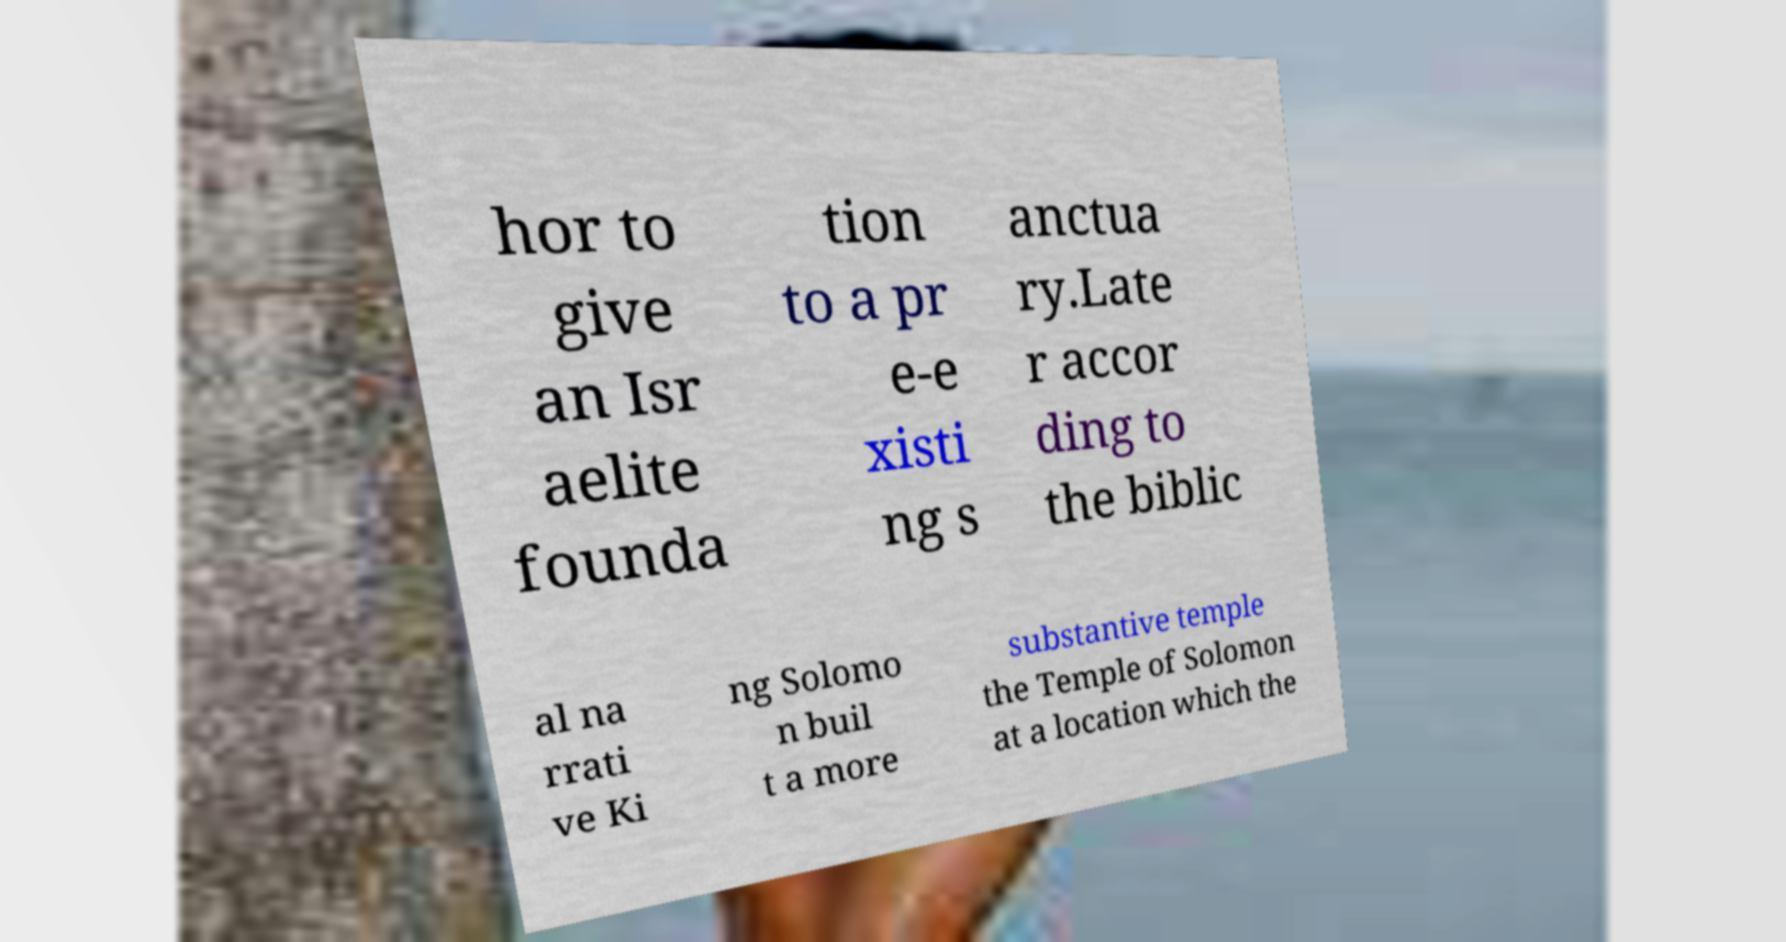Could you assist in decoding the text presented in this image and type it out clearly? hor to give an Isr aelite founda tion to a pr e-e xisti ng s anctua ry.Late r accor ding to the biblic al na rrati ve Ki ng Solomo n buil t a more substantive temple the Temple of Solomon at a location which the 